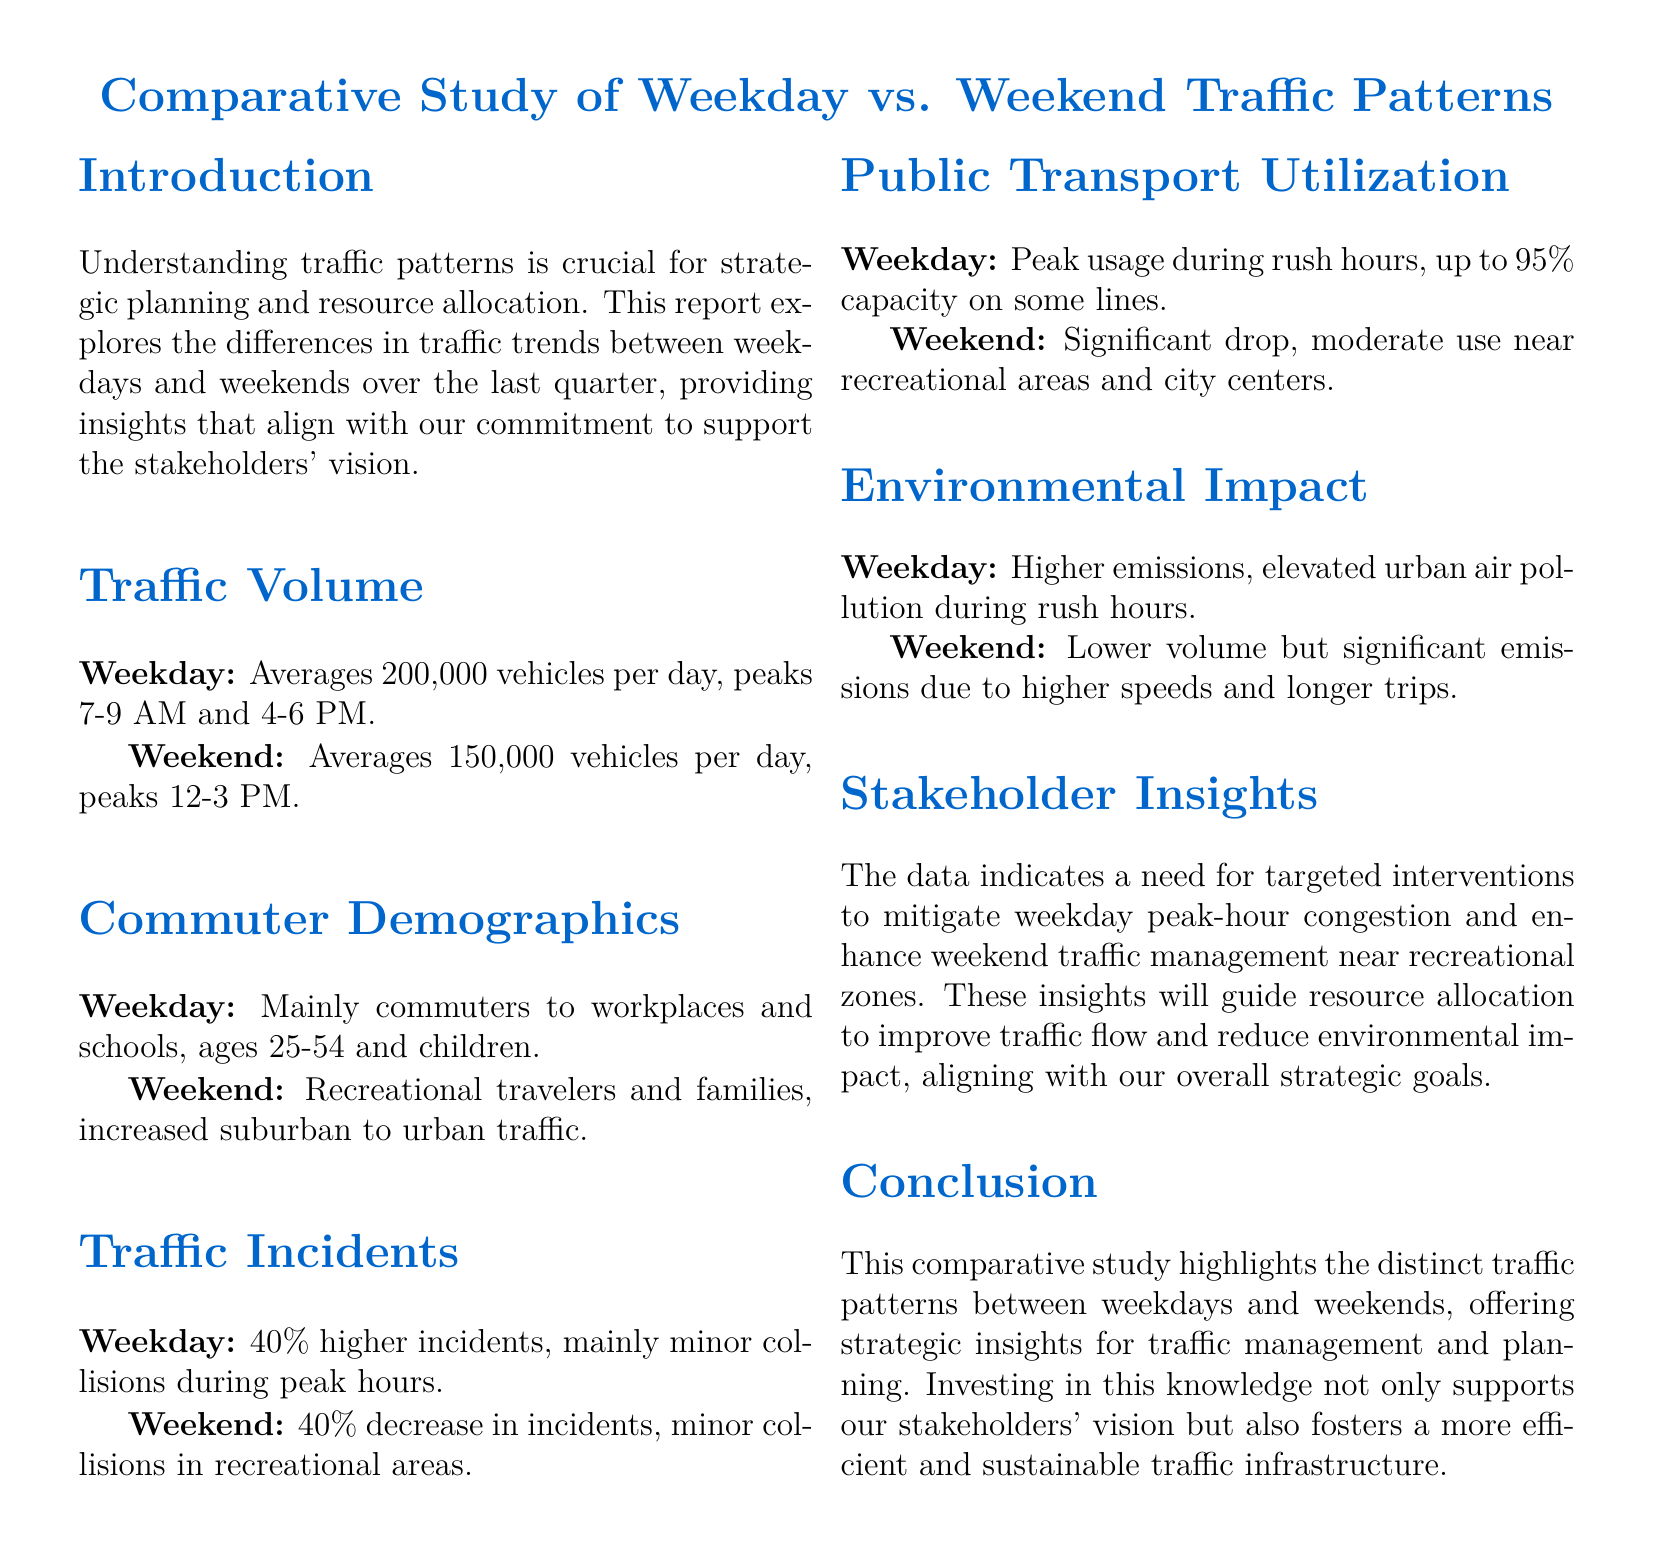what is the average weekday traffic volume? The average weekday traffic volume is mentioned in the Traffic Volume section, which indicates that it is 200,000 vehicles per day.
Answer: 200,000 vehicles per day what demographic mainly travels on weekdays? The Commuter Demographics section states that the demographic mainly consists of commuters to workplaces and schools, ages 25-54 and children.
Answer: commuters to workplaces and schools, ages 25-54 and children what is the peak hour for weekend traffic? The Traffic Volume section notes that weekend traffic peaks between 12-3 PM.
Answer: 12-3 PM how much higher are weekday traffic incidents compared to weekends? The Traffic Incidents section specifies that weekday traffic incidents are 40% higher than weekend incidents.
Answer: 40% how does public transport capacity differ between weekdays and weekends? The Public Transport Utilization section reveals that weekday capacity can reach up to 95%, compared to a significant drop in usage on weekends.
Answer: up to 95% why is it important to understand traffic patterns? The Introduction highlights that understanding traffic patterns is crucial for strategic planning and resource allocation.
Answer: strategic planning and resource allocation what was observed about traffic emissions on weekdays? The Environmental Impact section states that weekdays have higher emissions and elevated urban air pollution during rush hours.
Answer: higher emissions and elevated urban air pollution what does the report suggest about recreational areas during weekends? The Traffic Incidents section mentions that incidents during the weekend are mainly minor collisions in recreational areas.
Answer: minor collisions in recreational areas what is the objective of the stakeholder insights section? The Stakeholder Insights section indicates a need for targeted interventions to mitigate issues and enhance traffic management.
Answer: targeted interventions to mitigate issues and enhance traffic management 